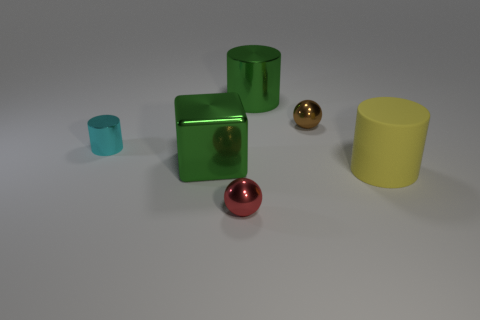Describe the material of the objects, please. The cubes and the cup give the impression of being made of a matte, possibly plastic material. The spheres look metallic with a reflective surface, and the cylinder appears to have a smooth, matte finish as well.  What does the lighting in the scene suggest to you? The lighting appears to be soft and diffuse, possibly from an overhead source. The shadows are soft-edged and there's a slight reflection on the shiny surfaces which indicates the environment is evenly lit. 